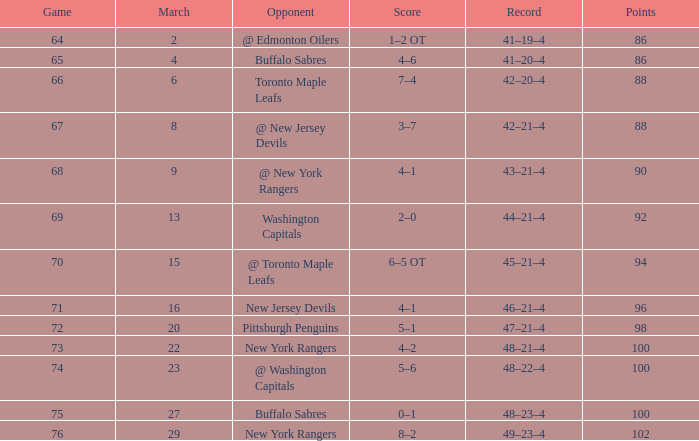For which points is there a 45-21-4 record and a game over 70 in size? None. 